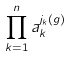<formula> <loc_0><loc_0><loc_500><loc_500>\prod _ { k = 1 } ^ { n } a _ { k } ^ { j _ { k } ( g ) }</formula> 